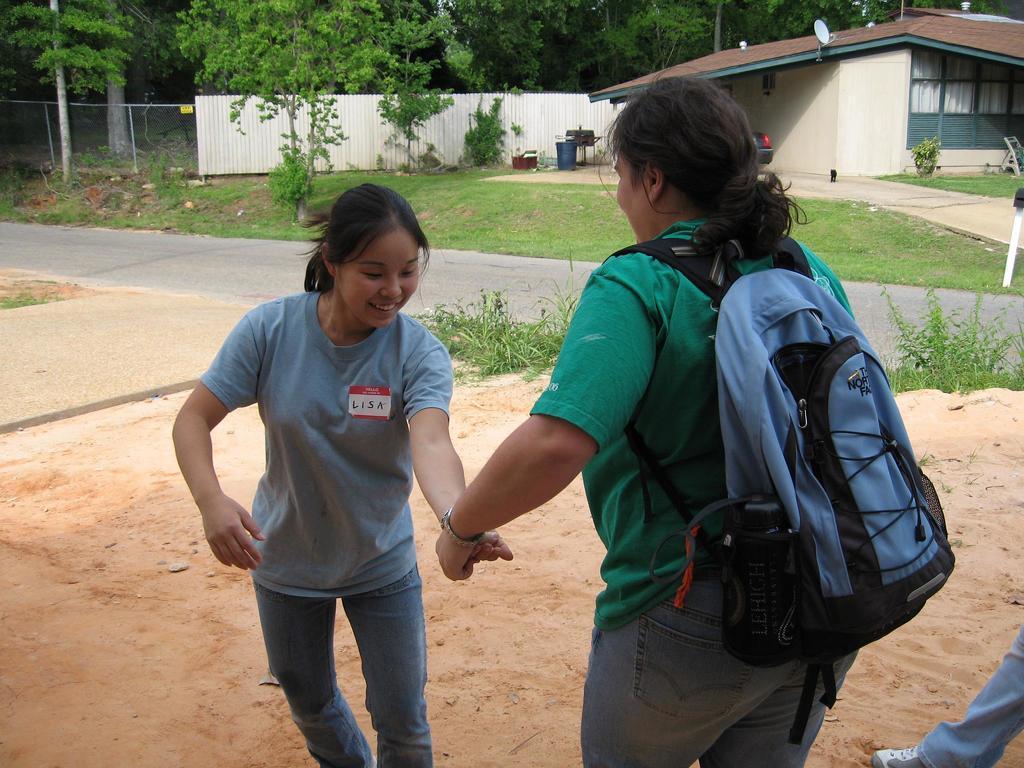How would you summarize this image in a sentence or two? In this picture we can see two woman standing on outdoor, the woman in front is carrying a bag, in the background we can see some grass and trees, there is a house on the right side of the picture. 